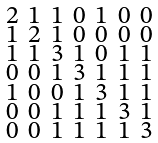Convert formula to latex. <formula><loc_0><loc_0><loc_500><loc_500>\begin{smallmatrix} 2 & 1 & 1 & 0 & 1 & 0 & 0 \\ 1 & 2 & 1 & 0 & 0 & 0 & 0 \\ 1 & 1 & 3 & 1 & 0 & 1 & 1 \\ 0 & 0 & 1 & 3 & 1 & 1 & 1 \\ 1 & 0 & 0 & 1 & 3 & 1 & 1 \\ 0 & 0 & 1 & 1 & 1 & 3 & 1 \\ 0 & 0 & 1 & 1 & 1 & 1 & 3 \end{smallmatrix}</formula> 